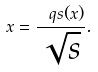Convert formula to latex. <formula><loc_0><loc_0><loc_500><loc_500>x = \frac { \ q s ( x ) } { \sqrt { s } } .</formula> 